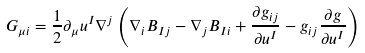Convert formula to latex. <formula><loc_0><loc_0><loc_500><loc_500>G _ { \mu i } = \frac { 1 } { 2 } \partial _ { \mu } u ^ { I } \nabla ^ { j } \left ( \nabla _ { i } B _ { I j } - \nabla _ { j } B _ { I i } + \frac { \partial g _ { i j } } { \partial u ^ { I } } - g _ { i j } \frac { \partial g } { \partial u ^ { I } } \right )</formula> 